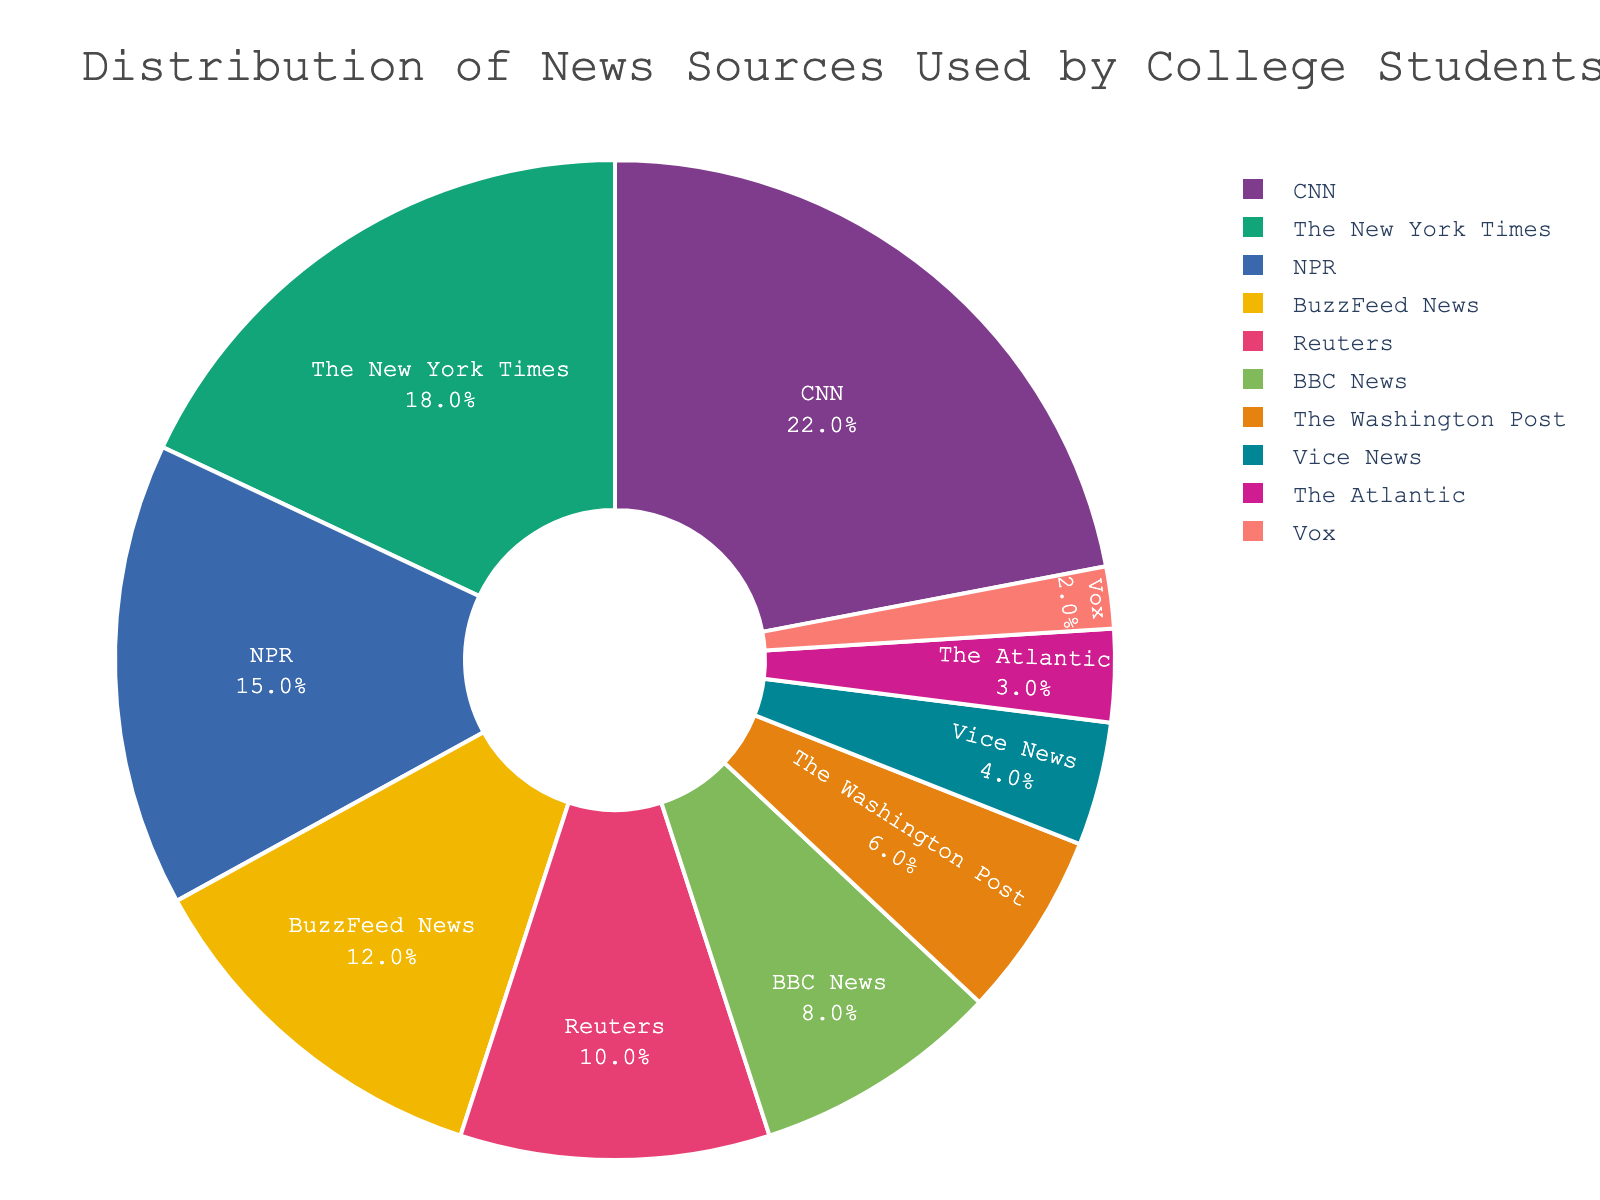What percentage of college students use The New York Times as their news source? The slice labeled "The New York Times" shows the percentage.
Answer: 18% Which news source is used the most by college students? The largest slice of the pie chart corresponds to the news source used the most, which is CNN.
Answer: CNN What is the combined percentage of students who use BuzzFeed News and Vice News? Add the percentage values for BuzzFeed News (12%) and Vice News (4%).
Answer: 16% Is the percentage of students who use NPR greater than those who use BBC News? Compare the slices labeled "NPR" (15%) and "BBC News" (8%).
Answer: Yes Which news source has the smallest slice in the chart, and what percentage does it represent? The smallest slice corresponds to Vox and represents 2%.
Answer: Vox, 2% How much greater is the percentage of students who use Reuters compared to those who use The Washington Post? Subtract the percentage for The Washington Post (6%) from Reuters (10%).
Answer: 4% Are the percentages for CNN and The New York Times combined greater than the sum of NPR and BuzzFeed News? Add the percentages: CNN (22%) + The New York Times (18%) = 40%, NPR (15%) + BuzzFeed News (12%) = 27%. 40% is greater than 27%.
Answer: Yes What is the total percentage of students who use either BBC News or The Atlantic? Add the percentages: BBC News (8%) + The Atlantic (3%) = 11%.
Answer: 11% Which has a higher percentage: Vice News or The Atlantic? Compare the slices labeled "Vice News" (4%) and "The Atlantic" (3%).
Answer: Vice News What is the difference in percentage between the highest and lowest news source categories? Subtract the smallest percentage (Vox, 2%) from the largest percentage (CNN, 22%).
Answer: 20% 